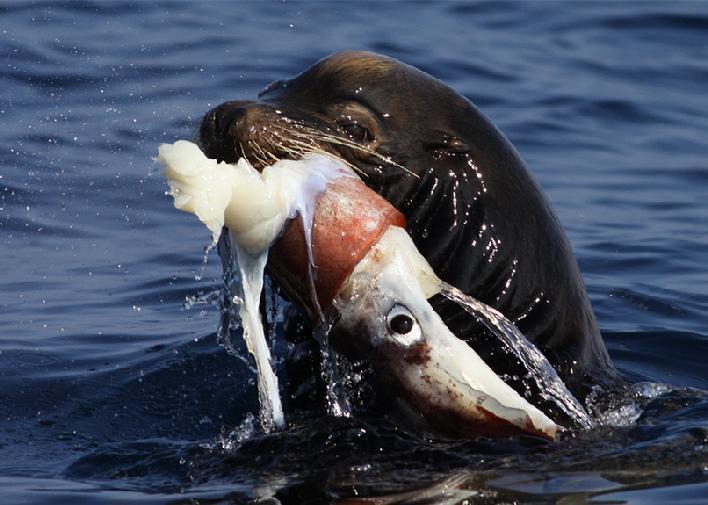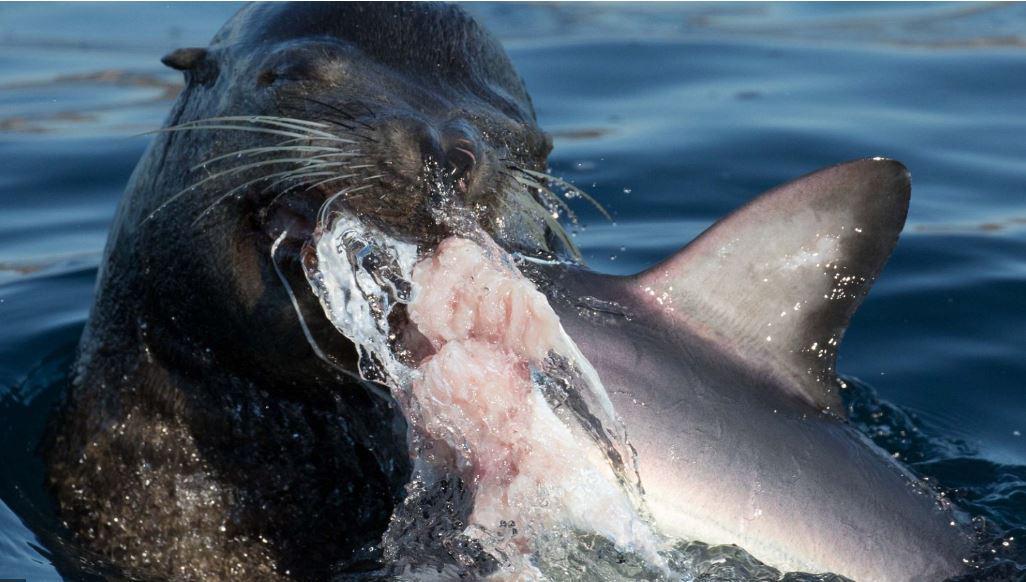The first image is the image on the left, the second image is the image on the right. For the images shown, is this caption "The seal in the left image is facing left with food in its mouth." true? Answer yes or no. Yes. The first image is the image on the left, the second image is the image on the right. Given the left and right images, does the statement "All of the images contains only animals and water and nothing else." hold true? Answer yes or no. Yes. 